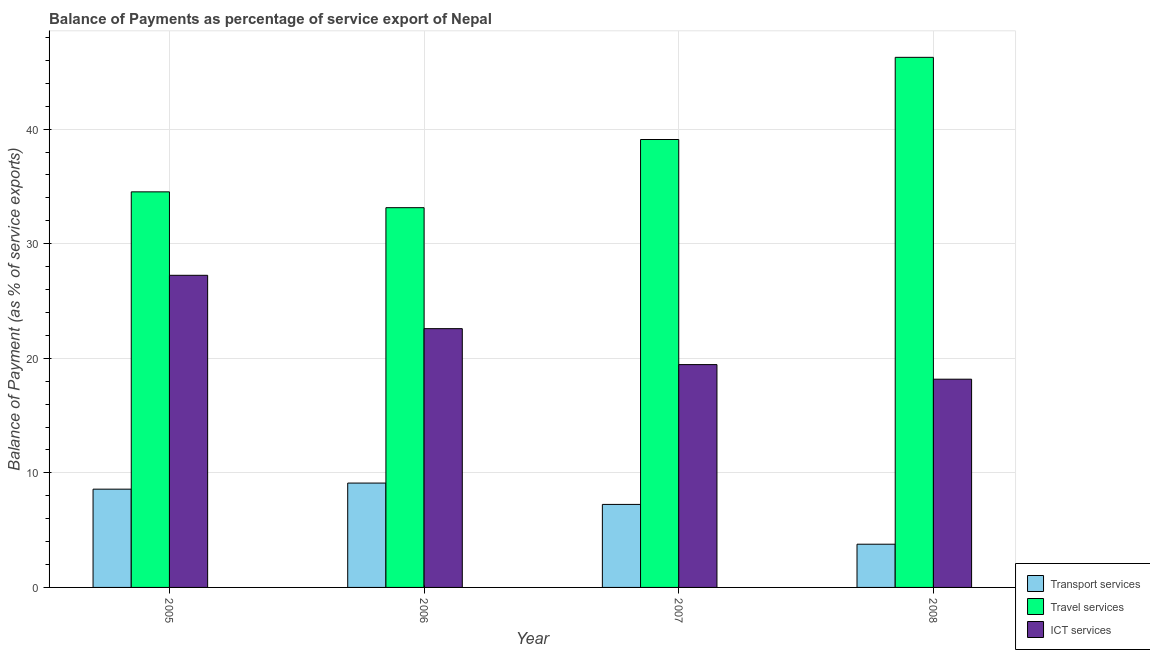How many different coloured bars are there?
Provide a short and direct response. 3. Are the number of bars per tick equal to the number of legend labels?
Offer a very short reply. Yes. What is the label of the 3rd group of bars from the left?
Provide a short and direct response. 2007. What is the balance of payment of transport services in 2008?
Ensure brevity in your answer.  3.77. Across all years, what is the maximum balance of payment of travel services?
Your answer should be very brief. 46.26. Across all years, what is the minimum balance of payment of travel services?
Provide a short and direct response. 33.14. In which year was the balance of payment of ict services maximum?
Give a very brief answer. 2005. What is the total balance of payment of ict services in the graph?
Your answer should be compact. 87.45. What is the difference between the balance of payment of ict services in 2005 and that in 2008?
Provide a succinct answer. 9.07. What is the difference between the balance of payment of transport services in 2006 and the balance of payment of ict services in 2008?
Give a very brief answer. 5.34. What is the average balance of payment of travel services per year?
Your answer should be compact. 38.26. What is the ratio of the balance of payment of travel services in 2006 to that in 2007?
Your answer should be very brief. 0.85. What is the difference between the highest and the second highest balance of payment of travel services?
Make the answer very short. 7.17. What is the difference between the highest and the lowest balance of payment of transport services?
Keep it short and to the point. 5.34. What does the 1st bar from the left in 2007 represents?
Provide a succinct answer. Transport services. What does the 2nd bar from the right in 2007 represents?
Provide a short and direct response. Travel services. Is it the case that in every year, the sum of the balance of payment of transport services and balance of payment of travel services is greater than the balance of payment of ict services?
Keep it short and to the point. Yes. Are all the bars in the graph horizontal?
Offer a very short reply. No. Are the values on the major ticks of Y-axis written in scientific E-notation?
Your answer should be very brief. No. Does the graph contain grids?
Make the answer very short. Yes. How many legend labels are there?
Make the answer very short. 3. What is the title of the graph?
Ensure brevity in your answer.  Balance of Payments as percentage of service export of Nepal. What is the label or title of the X-axis?
Give a very brief answer. Year. What is the label or title of the Y-axis?
Keep it short and to the point. Balance of Payment (as % of service exports). What is the Balance of Payment (as % of service exports) in Transport services in 2005?
Provide a short and direct response. 8.58. What is the Balance of Payment (as % of service exports) in Travel services in 2005?
Your answer should be compact. 34.52. What is the Balance of Payment (as % of service exports) of ICT services in 2005?
Provide a succinct answer. 27.24. What is the Balance of Payment (as % of service exports) in Transport services in 2006?
Offer a very short reply. 9.11. What is the Balance of Payment (as % of service exports) of Travel services in 2006?
Ensure brevity in your answer.  33.14. What is the Balance of Payment (as % of service exports) in ICT services in 2006?
Ensure brevity in your answer.  22.59. What is the Balance of Payment (as % of service exports) in Transport services in 2007?
Your answer should be compact. 7.24. What is the Balance of Payment (as % of service exports) in Travel services in 2007?
Provide a succinct answer. 39.09. What is the Balance of Payment (as % of service exports) of ICT services in 2007?
Provide a succinct answer. 19.45. What is the Balance of Payment (as % of service exports) of Transport services in 2008?
Your response must be concise. 3.77. What is the Balance of Payment (as % of service exports) of Travel services in 2008?
Your answer should be very brief. 46.26. What is the Balance of Payment (as % of service exports) of ICT services in 2008?
Your response must be concise. 18.17. Across all years, what is the maximum Balance of Payment (as % of service exports) of Transport services?
Offer a terse response. 9.11. Across all years, what is the maximum Balance of Payment (as % of service exports) of Travel services?
Give a very brief answer. 46.26. Across all years, what is the maximum Balance of Payment (as % of service exports) in ICT services?
Your answer should be compact. 27.24. Across all years, what is the minimum Balance of Payment (as % of service exports) in Transport services?
Provide a succinct answer. 3.77. Across all years, what is the minimum Balance of Payment (as % of service exports) of Travel services?
Offer a very short reply. 33.14. Across all years, what is the minimum Balance of Payment (as % of service exports) of ICT services?
Your answer should be very brief. 18.17. What is the total Balance of Payment (as % of service exports) in Transport services in the graph?
Your answer should be very brief. 28.7. What is the total Balance of Payment (as % of service exports) of Travel services in the graph?
Provide a short and direct response. 153.02. What is the total Balance of Payment (as % of service exports) in ICT services in the graph?
Your response must be concise. 87.45. What is the difference between the Balance of Payment (as % of service exports) in Transport services in 2005 and that in 2006?
Offer a very short reply. -0.53. What is the difference between the Balance of Payment (as % of service exports) of Travel services in 2005 and that in 2006?
Provide a succinct answer. 1.38. What is the difference between the Balance of Payment (as % of service exports) of ICT services in 2005 and that in 2006?
Your answer should be very brief. 4.66. What is the difference between the Balance of Payment (as % of service exports) in Transport services in 2005 and that in 2007?
Your answer should be compact. 1.33. What is the difference between the Balance of Payment (as % of service exports) of Travel services in 2005 and that in 2007?
Offer a terse response. -4.57. What is the difference between the Balance of Payment (as % of service exports) of ICT services in 2005 and that in 2007?
Your answer should be compact. 7.79. What is the difference between the Balance of Payment (as % of service exports) of Transport services in 2005 and that in 2008?
Provide a succinct answer. 4.8. What is the difference between the Balance of Payment (as % of service exports) in Travel services in 2005 and that in 2008?
Your answer should be compact. -11.74. What is the difference between the Balance of Payment (as % of service exports) of ICT services in 2005 and that in 2008?
Your response must be concise. 9.07. What is the difference between the Balance of Payment (as % of service exports) in Transport services in 2006 and that in 2007?
Your response must be concise. 1.86. What is the difference between the Balance of Payment (as % of service exports) in Travel services in 2006 and that in 2007?
Make the answer very short. -5.95. What is the difference between the Balance of Payment (as % of service exports) in ICT services in 2006 and that in 2007?
Provide a succinct answer. 3.14. What is the difference between the Balance of Payment (as % of service exports) of Transport services in 2006 and that in 2008?
Give a very brief answer. 5.34. What is the difference between the Balance of Payment (as % of service exports) of Travel services in 2006 and that in 2008?
Make the answer very short. -13.12. What is the difference between the Balance of Payment (as % of service exports) in ICT services in 2006 and that in 2008?
Offer a very short reply. 4.41. What is the difference between the Balance of Payment (as % of service exports) of Transport services in 2007 and that in 2008?
Provide a short and direct response. 3.47. What is the difference between the Balance of Payment (as % of service exports) in Travel services in 2007 and that in 2008?
Keep it short and to the point. -7.17. What is the difference between the Balance of Payment (as % of service exports) in ICT services in 2007 and that in 2008?
Ensure brevity in your answer.  1.27. What is the difference between the Balance of Payment (as % of service exports) of Transport services in 2005 and the Balance of Payment (as % of service exports) of Travel services in 2006?
Offer a terse response. -24.57. What is the difference between the Balance of Payment (as % of service exports) of Transport services in 2005 and the Balance of Payment (as % of service exports) of ICT services in 2006?
Provide a succinct answer. -14.01. What is the difference between the Balance of Payment (as % of service exports) of Travel services in 2005 and the Balance of Payment (as % of service exports) of ICT services in 2006?
Offer a very short reply. 11.94. What is the difference between the Balance of Payment (as % of service exports) of Transport services in 2005 and the Balance of Payment (as % of service exports) of Travel services in 2007?
Your answer should be compact. -30.52. What is the difference between the Balance of Payment (as % of service exports) of Transport services in 2005 and the Balance of Payment (as % of service exports) of ICT services in 2007?
Give a very brief answer. -10.87. What is the difference between the Balance of Payment (as % of service exports) of Travel services in 2005 and the Balance of Payment (as % of service exports) of ICT services in 2007?
Your answer should be very brief. 15.08. What is the difference between the Balance of Payment (as % of service exports) of Transport services in 2005 and the Balance of Payment (as % of service exports) of Travel services in 2008?
Your answer should be compact. -37.69. What is the difference between the Balance of Payment (as % of service exports) of Transport services in 2005 and the Balance of Payment (as % of service exports) of ICT services in 2008?
Provide a short and direct response. -9.6. What is the difference between the Balance of Payment (as % of service exports) in Travel services in 2005 and the Balance of Payment (as % of service exports) in ICT services in 2008?
Give a very brief answer. 16.35. What is the difference between the Balance of Payment (as % of service exports) in Transport services in 2006 and the Balance of Payment (as % of service exports) in Travel services in 2007?
Provide a succinct answer. -29.98. What is the difference between the Balance of Payment (as % of service exports) in Transport services in 2006 and the Balance of Payment (as % of service exports) in ICT services in 2007?
Your answer should be compact. -10.34. What is the difference between the Balance of Payment (as % of service exports) in Travel services in 2006 and the Balance of Payment (as % of service exports) in ICT services in 2007?
Give a very brief answer. 13.7. What is the difference between the Balance of Payment (as % of service exports) in Transport services in 2006 and the Balance of Payment (as % of service exports) in Travel services in 2008?
Your answer should be compact. -37.16. What is the difference between the Balance of Payment (as % of service exports) in Transport services in 2006 and the Balance of Payment (as % of service exports) in ICT services in 2008?
Offer a terse response. -9.07. What is the difference between the Balance of Payment (as % of service exports) of Travel services in 2006 and the Balance of Payment (as % of service exports) of ICT services in 2008?
Provide a succinct answer. 14.97. What is the difference between the Balance of Payment (as % of service exports) of Transport services in 2007 and the Balance of Payment (as % of service exports) of Travel services in 2008?
Give a very brief answer. -39.02. What is the difference between the Balance of Payment (as % of service exports) in Transport services in 2007 and the Balance of Payment (as % of service exports) in ICT services in 2008?
Ensure brevity in your answer.  -10.93. What is the difference between the Balance of Payment (as % of service exports) of Travel services in 2007 and the Balance of Payment (as % of service exports) of ICT services in 2008?
Offer a terse response. 20.92. What is the average Balance of Payment (as % of service exports) of Transport services per year?
Your answer should be compact. 7.18. What is the average Balance of Payment (as % of service exports) in Travel services per year?
Your answer should be compact. 38.26. What is the average Balance of Payment (as % of service exports) of ICT services per year?
Offer a terse response. 21.86. In the year 2005, what is the difference between the Balance of Payment (as % of service exports) in Transport services and Balance of Payment (as % of service exports) in Travel services?
Offer a terse response. -25.95. In the year 2005, what is the difference between the Balance of Payment (as % of service exports) in Transport services and Balance of Payment (as % of service exports) in ICT services?
Offer a very short reply. -18.66. In the year 2005, what is the difference between the Balance of Payment (as % of service exports) in Travel services and Balance of Payment (as % of service exports) in ICT services?
Provide a short and direct response. 7.28. In the year 2006, what is the difference between the Balance of Payment (as % of service exports) of Transport services and Balance of Payment (as % of service exports) of Travel services?
Make the answer very short. -24.03. In the year 2006, what is the difference between the Balance of Payment (as % of service exports) of Transport services and Balance of Payment (as % of service exports) of ICT services?
Ensure brevity in your answer.  -13.48. In the year 2006, what is the difference between the Balance of Payment (as % of service exports) of Travel services and Balance of Payment (as % of service exports) of ICT services?
Offer a terse response. 10.56. In the year 2007, what is the difference between the Balance of Payment (as % of service exports) in Transport services and Balance of Payment (as % of service exports) in Travel services?
Your answer should be compact. -31.85. In the year 2007, what is the difference between the Balance of Payment (as % of service exports) in Transport services and Balance of Payment (as % of service exports) in ICT services?
Your answer should be very brief. -12.2. In the year 2007, what is the difference between the Balance of Payment (as % of service exports) in Travel services and Balance of Payment (as % of service exports) in ICT services?
Provide a short and direct response. 19.65. In the year 2008, what is the difference between the Balance of Payment (as % of service exports) in Transport services and Balance of Payment (as % of service exports) in Travel services?
Offer a terse response. -42.49. In the year 2008, what is the difference between the Balance of Payment (as % of service exports) in Transport services and Balance of Payment (as % of service exports) in ICT services?
Make the answer very short. -14.4. In the year 2008, what is the difference between the Balance of Payment (as % of service exports) of Travel services and Balance of Payment (as % of service exports) of ICT services?
Keep it short and to the point. 28.09. What is the ratio of the Balance of Payment (as % of service exports) in Transport services in 2005 to that in 2006?
Provide a short and direct response. 0.94. What is the ratio of the Balance of Payment (as % of service exports) in Travel services in 2005 to that in 2006?
Ensure brevity in your answer.  1.04. What is the ratio of the Balance of Payment (as % of service exports) in ICT services in 2005 to that in 2006?
Your response must be concise. 1.21. What is the ratio of the Balance of Payment (as % of service exports) of Transport services in 2005 to that in 2007?
Provide a short and direct response. 1.18. What is the ratio of the Balance of Payment (as % of service exports) in Travel services in 2005 to that in 2007?
Provide a succinct answer. 0.88. What is the ratio of the Balance of Payment (as % of service exports) of ICT services in 2005 to that in 2007?
Your response must be concise. 1.4. What is the ratio of the Balance of Payment (as % of service exports) in Transport services in 2005 to that in 2008?
Your answer should be very brief. 2.27. What is the ratio of the Balance of Payment (as % of service exports) of Travel services in 2005 to that in 2008?
Your response must be concise. 0.75. What is the ratio of the Balance of Payment (as % of service exports) of ICT services in 2005 to that in 2008?
Provide a short and direct response. 1.5. What is the ratio of the Balance of Payment (as % of service exports) in Transport services in 2006 to that in 2007?
Provide a succinct answer. 1.26. What is the ratio of the Balance of Payment (as % of service exports) in Travel services in 2006 to that in 2007?
Your response must be concise. 0.85. What is the ratio of the Balance of Payment (as % of service exports) of ICT services in 2006 to that in 2007?
Offer a terse response. 1.16. What is the ratio of the Balance of Payment (as % of service exports) in Transport services in 2006 to that in 2008?
Your answer should be compact. 2.41. What is the ratio of the Balance of Payment (as % of service exports) in Travel services in 2006 to that in 2008?
Make the answer very short. 0.72. What is the ratio of the Balance of Payment (as % of service exports) in ICT services in 2006 to that in 2008?
Keep it short and to the point. 1.24. What is the ratio of the Balance of Payment (as % of service exports) in Transport services in 2007 to that in 2008?
Provide a short and direct response. 1.92. What is the ratio of the Balance of Payment (as % of service exports) in Travel services in 2007 to that in 2008?
Keep it short and to the point. 0.84. What is the ratio of the Balance of Payment (as % of service exports) in ICT services in 2007 to that in 2008?
Your response must be concise. 1.07. What is the difference between the highest and the second highest Balance of Payment (as % of service exports) in Transport services?
Offer a terse response. 0.53. What is the difference between the highest and the second highest Balance of Payment (as % of service exports) in Travel services?
Provide a succinct answer. 7.17. What is the difference between the highest and the second highest Balance of Payment (as % of service exports) of ICT services?
Offer a very short reply. 4.66. What is the difference between the highest and the lowest Balance of Payment (as % of service exports) in Transport services?
Ensure brevity in your answer.  5.34. What is the difference between the highest and the lowest Balance of Payment (as % of service exports) of Travel services?
Provide a short and direct response. 13.12. What is the difference between the highest and the lowest Balance of Payment (as % of service exports) in ICT services?
Give a very brief answer. 9.07. 